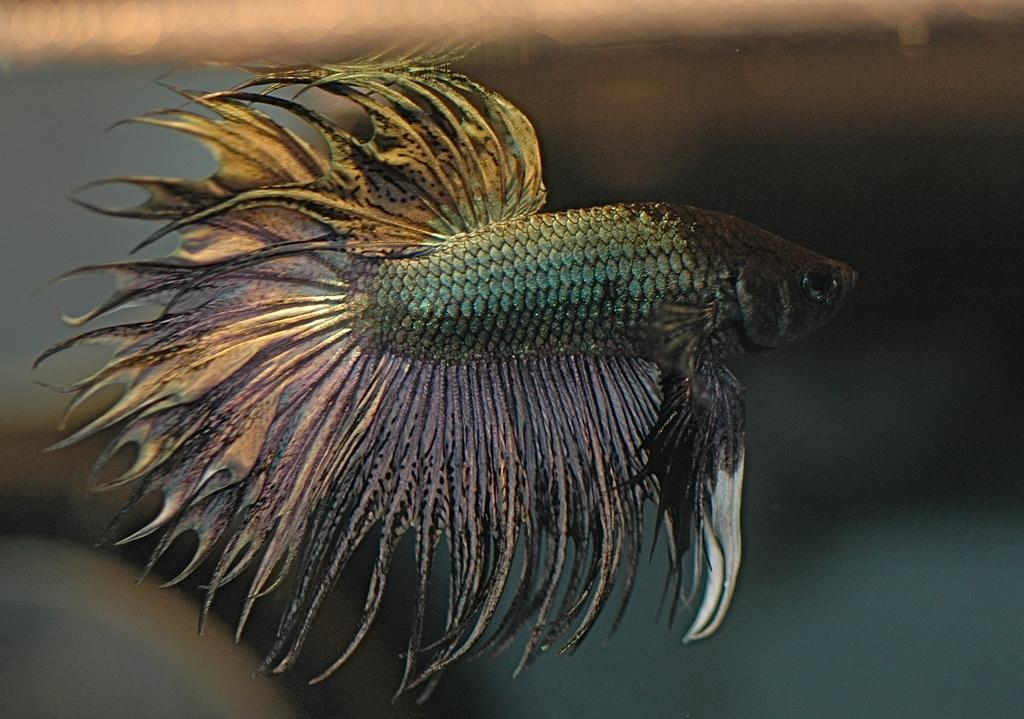What is the main subject of the image? There is a fish in the image. Can you describe the background of the image? The background of the image is blurry. What is the name of the laborer holding the chicken in the image? There is no laborer or chicken present in the image; it features a fish with a blurry background. 